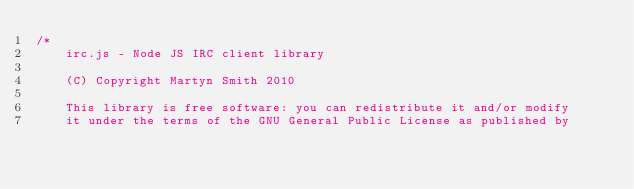<code> <loc_0><loc_0><loc_500><loc_500><_JavaScript_>/*
    irc.js - Node JS IRC client library

    (C) Copyright Martyn Smith 2010

    This library is free software: you can redistribute it and/or modify
    it under the terms of the GNU General Public License as published by</code> 